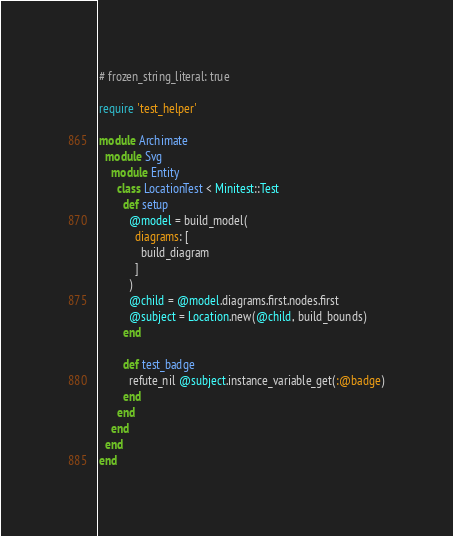<code> <loc_0><loc_0><loc_500><loc_500><_Ruby_># frozen_string_literal: true

require 'test_helper'

module Archimate
  module Svg
    module Entity
      class LocationTest < Minitest::Test
        def setup
          @model = build_model(
            diagrams: [
              build_diagram
            ]
          )
          @child = @model.diagrams.first.nodes.first
          @subject = Location.new(@child, build_bounds)
        end

        def test_badge
          refute_nil @subject.instance_variable_get(:@badge)
        end
      end
    end
  end
end
</code> 